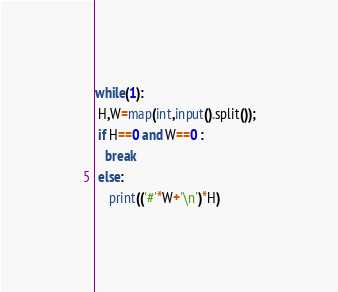Convert code to text. <code><loc_0><loc_0><loc_500><loc_500><_Python_>while(1):
 H,W=map(int,input().split());
 if H==0 and W==0 :
   break
 else: 
    print(('#'*W+'\n')*H) </code> 